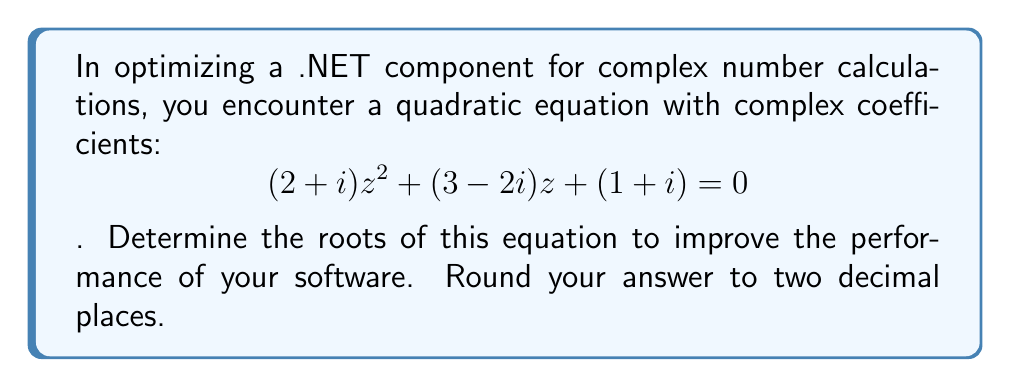Solve this math problem. To solve this quadratic equation with complex coefficients, we'll use the quadratic formula: $$z = \frac{-b \pm \sqrt{b^2 - 4ac}}{2a}$$

1) Identify the coefficients:
   $a = 2+i$
   $b = 3-2i$
   $c = 1+i$

2) Calculate $b^2$:
   $b^2 = (3-2i)^2 = 9 - 12i + 4i^2 = 5 - 12i$

3) Calculate $4ac$:
   $4ac = 4(2+i)(1+i) = 4(2+i+2i-1) = 4(1+3i) = 4 + 12i$

4) Calculate $b^2 - 4ac$:
   $b^2 - 4ac = (5-12i) - (4+12i) = 1 - 24i$

5) Calculate $\sqrt{b^2 - 4ac}$:
   $\sqrt{1-24i} \approx 3.61 - 3.32i$ (using complex square root)

6) Calculate $-b$:
   $-b = -(3-2i) = -3+2i$

7) Calculate $2a$:
   $2a = 2(2+i) = 4+2i$

8) Apply the quadratic formula:
   $z = \frac{(-3+2i) \pm (3.61-3.32i)}{4+2i}$

9) Simplify and calculate the two roots:
   $z_1 \approx -0.13 + 0.62i$
   $z_2 \approx -0.87 - 0.12i$
Answer: $z_1 \approx -0.13 + 0.62i$, $z_2 \approx -0.87 - 0.12i$ 